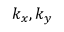<formula> <loc_0><loc_0><loc_500><loc_500>k _ { x } , k _ { y }</formula> 